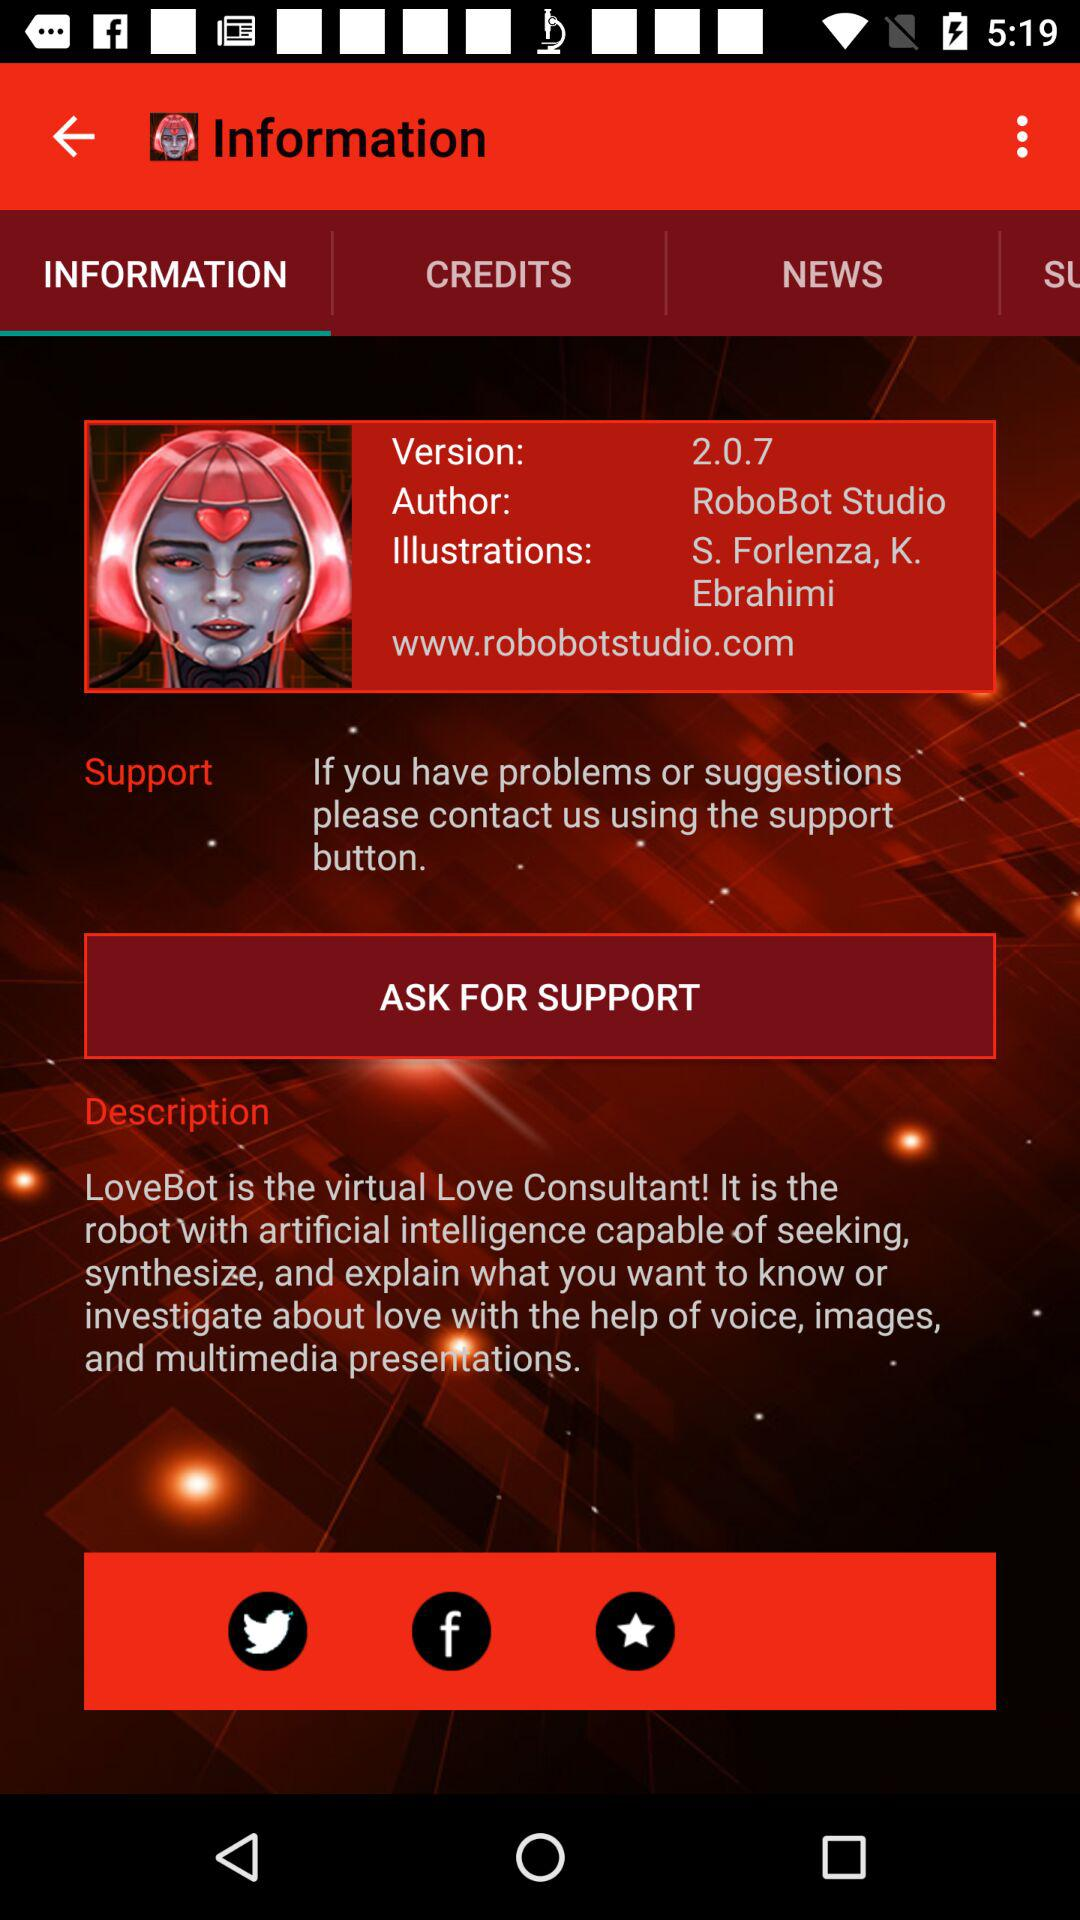What is the website? The website is www.robobotstudio.com. 